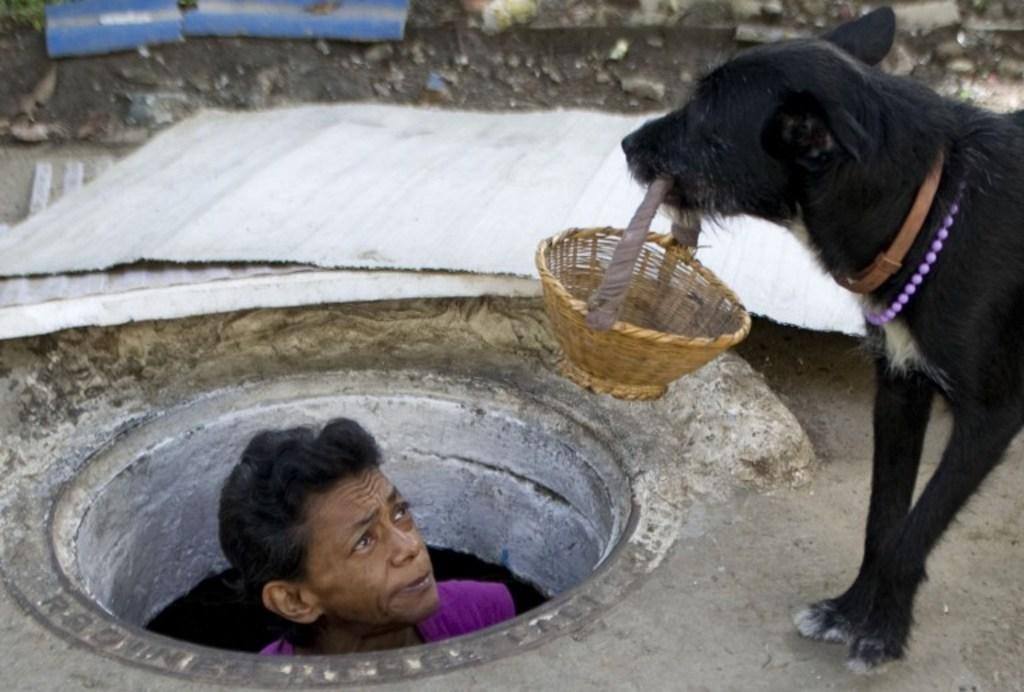What animal is present in the image? There is a dog in the image. What is the dog doing in the image? The dog is holding a basket in its mouth. Can you describe the person in the image? The person is in a pipe in the image. What type of materials can be seen in the image? Metal rods and stones are visible in the image. What can be inferred about the time of day when the image was taken? The image was likely taken during the day. What type of quartz can be seen in the image? There is no quartz present in the image. What is the army doing in the image? There is no army present in the image. What type of sink can be seen in the image? There is no sink present in the image. 